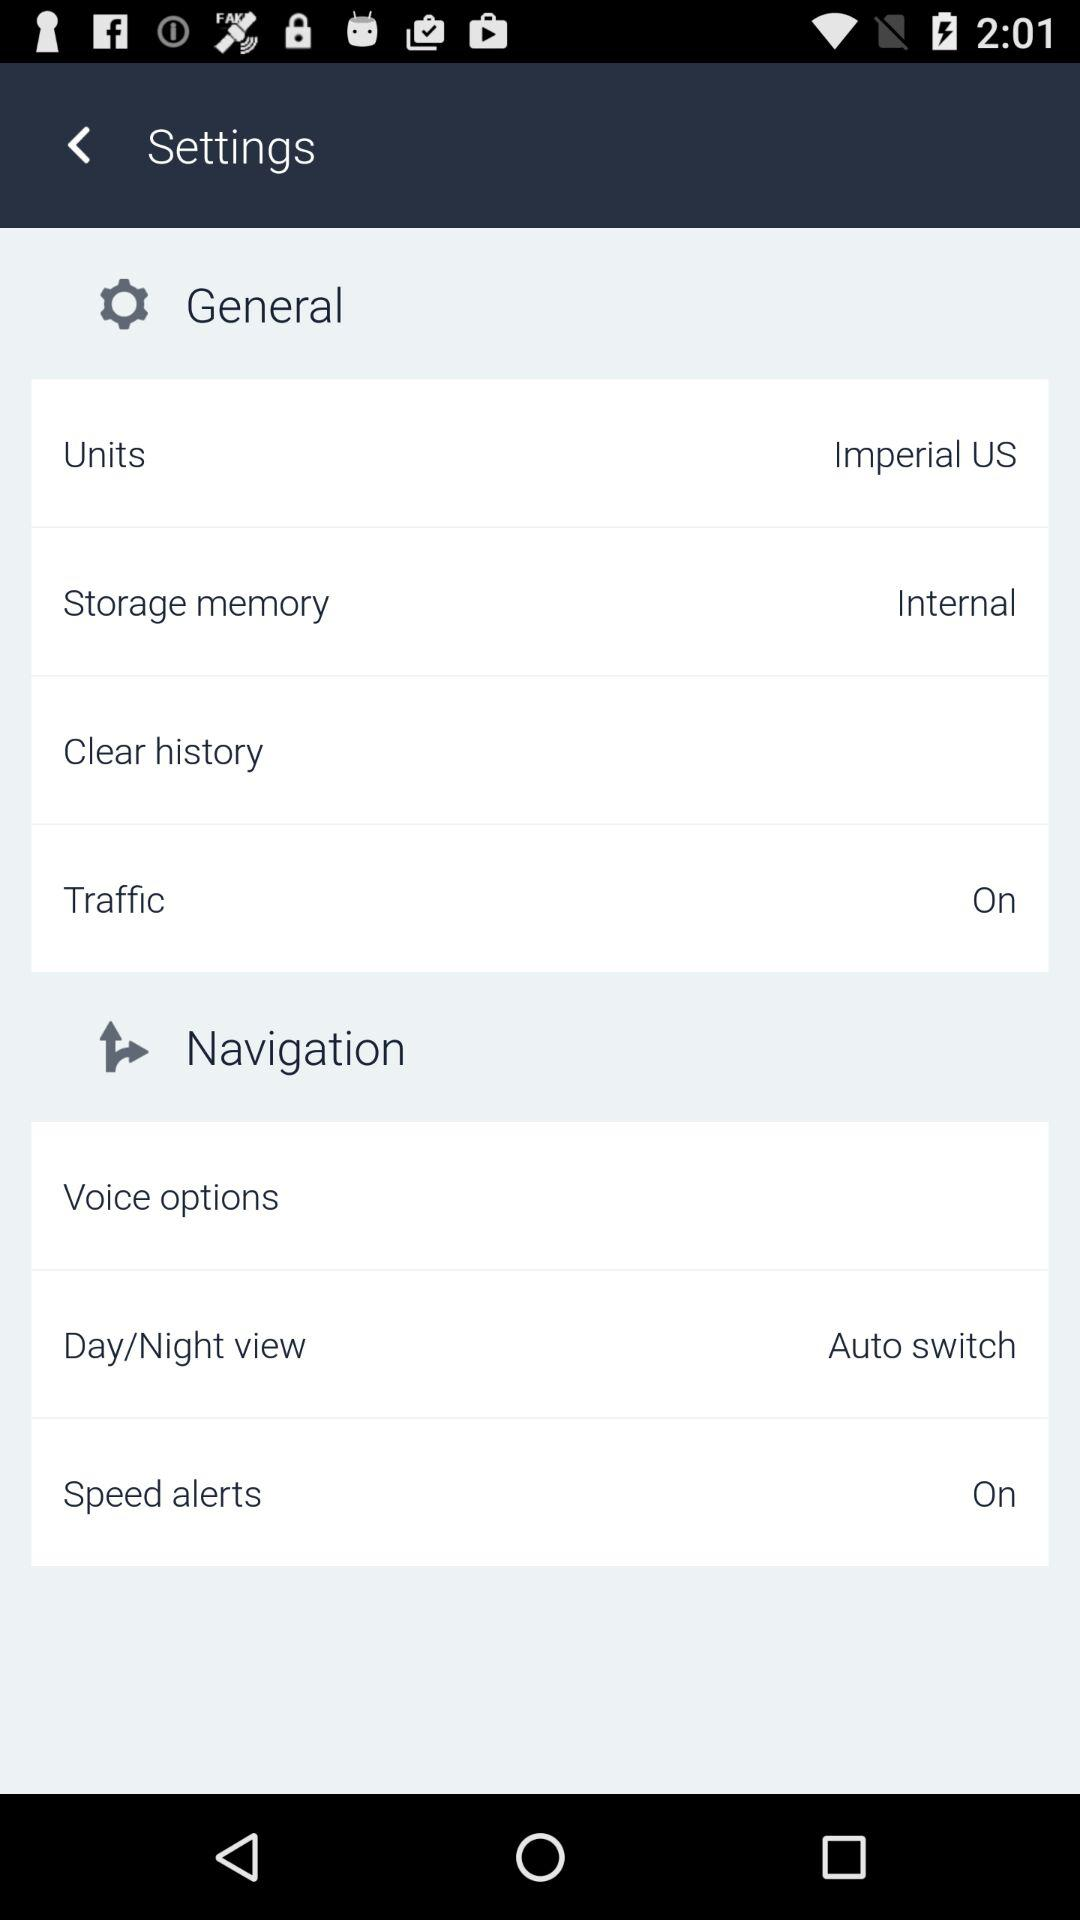What's the setting for "Day/Night view"? The setting is "Auto switch". 